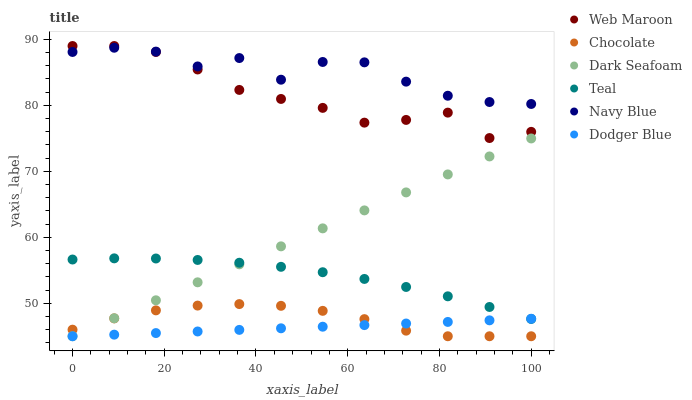Does Dodger Blue have the minimum area under the curve?
Answer yes or no. Yes. Does Navy Blue have the maximum area under the curve?
Answer yes or no. Yes. Does Web Maroon have the minimum area under the curve?
Answer yes or no. No. Does Web Maroon have the maximum area under the curve?
Answer yes or no. No. Is Dodger Blue the smoothest?
Answer yes or no. Yes. Is Navy Blue the roughest?
Answer yes or no. Yes. Is Web Maroon the smoothest?
Answer yes or no. No. Is Web Maroon the roughest?
Answer yes or no. No. Does Chocolate have the lowest value?
Answer yes or no. Yes. Does Web Maroon have the lowest value?
Answer yes or no. No. Does Web Maroon have the highest value?
Answer yes or no. Yes. Does Chocolate have the highest value?
Answer yes or no. No. Is Dodger Blue less than Navy Blue?
Answer yes or no. Yes. Is Web Maroon greater than Chocolate?
Answer yes or no. Yes. Does Dodger Blue intersect Teal?
Answer yes or no. Yes. Is Dodger Blue less than Teal?
Answer yes or no. No. Is Dodger Blue greater than Teal?
Answer yes or no. No. Does Dodger Blue intersect Navy Blue?
Answer yes or no. No. 